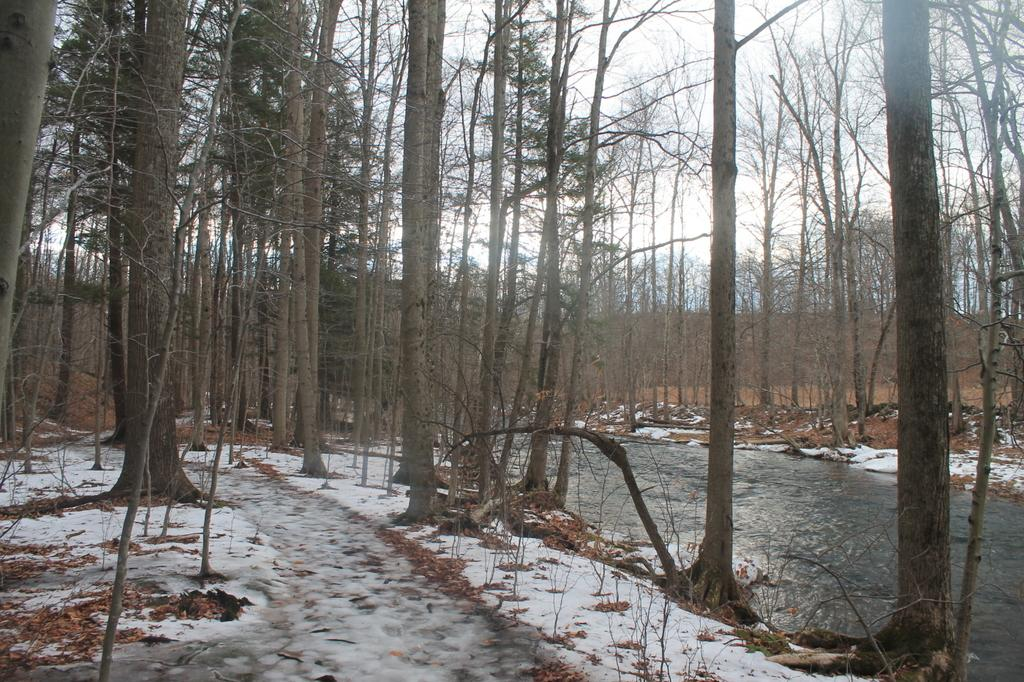What is located in the bottom left corner of the image? There is a ground in the bottom left corner of the image. What can be seen on the right side of the image? There is water on the right side of the image. What type of natural environment is visible in the background of the image? There are trees in the background of the image. What is the desire of the tree in the image? There is no indication of desire in the image, as trees do not have emotions or desires. How many arms are visible in the image? There are no arms visible in the image; it features a ground, water, and trees. 